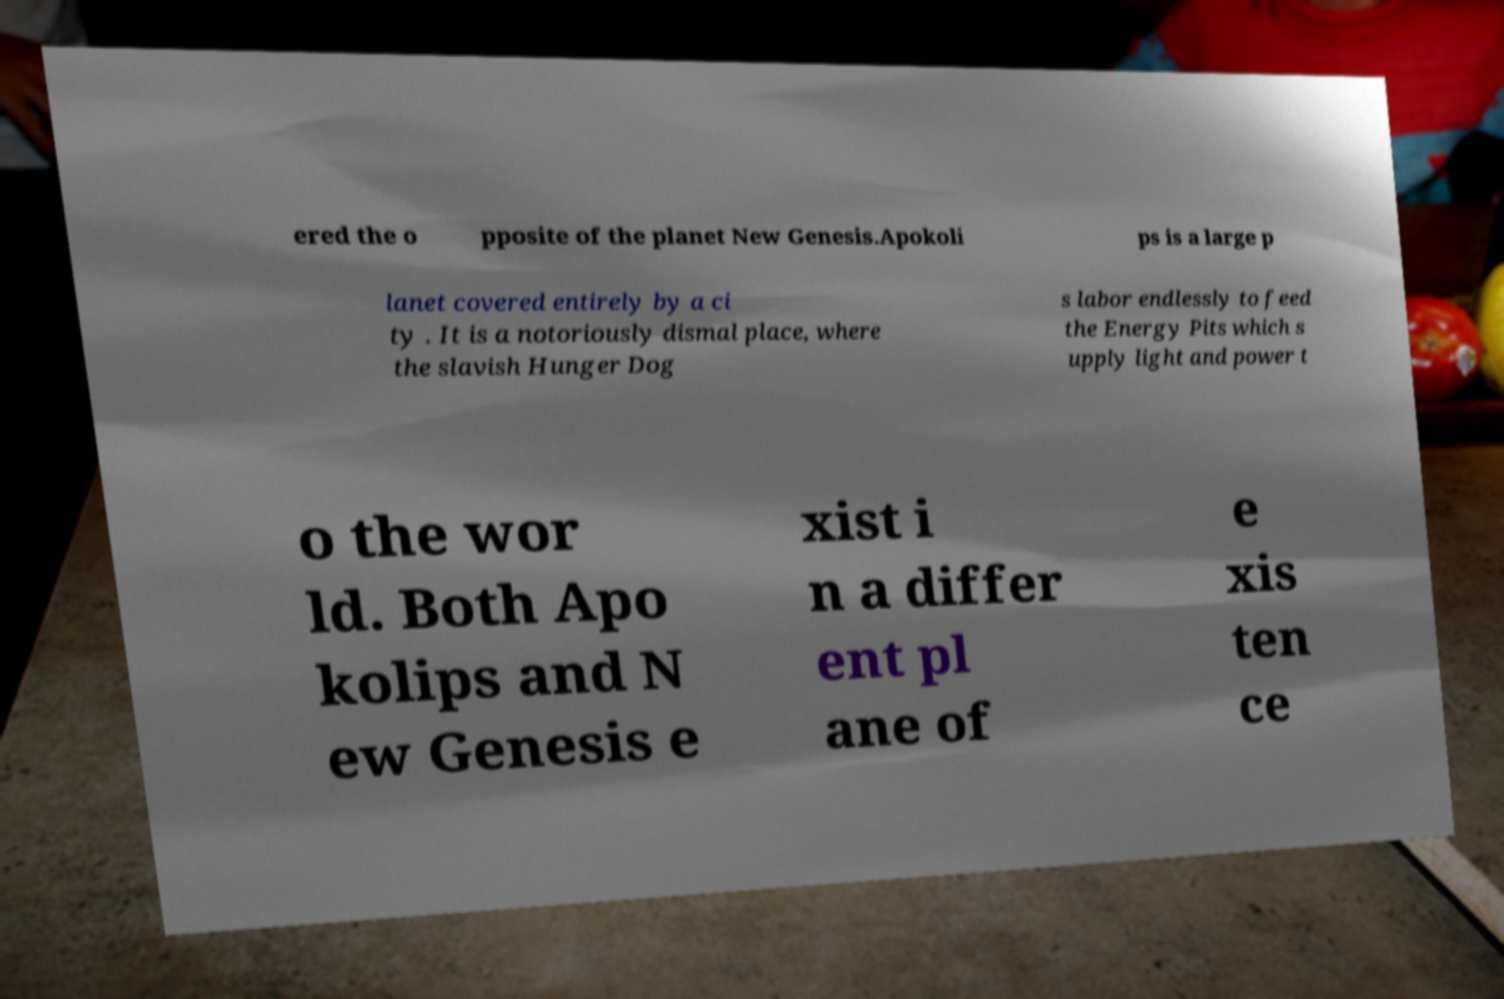What messages or text are displayed in this image? I need them in a readable, typed format. ered the o pposite of the planet New Genesis.Apokoli ps is a large p lanet covered entirely by a ci ty . It is a notoriously dismal place, where the slavish Hunger Dog s labor endlessly to feed the Energy Pits which s upply light and power t o the wor ld. Both Apo kolips and N ew Genesis e xist i n a differ ent pl ane of e xis ten ce 